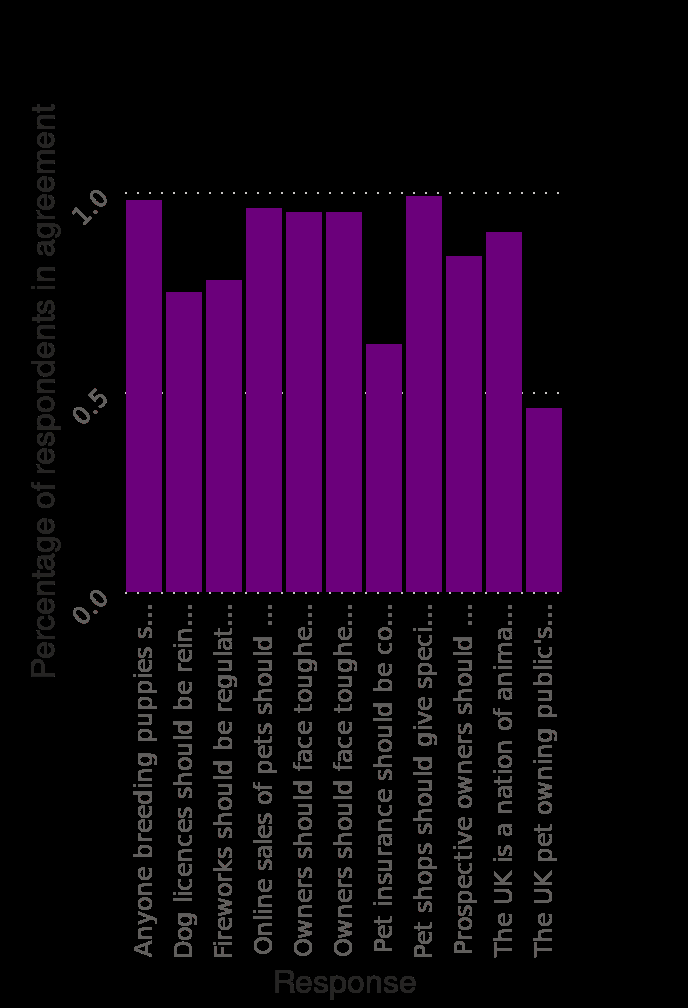<image>
Describe the following image in detail This is a bar diagram titled Veterinary professionals views on issues concerning pet ownership and choosing a pet in the United Kingdom (UK) in 2016. A categorical scale starting at Anyone breeding puppies should be licensed and regulated to meet certain standards. and ending at  can be found on the x-axis, marked Response. A linear scale with a minimum of 0.0 and a maximum of 1.0 can be found along the y-axis, marked Percentage of respondents in agreement. What was the highest percentage of respondents agreeing with any of the issues? The highest percentage of respondents agreeing with any of the issues was 1%. What is the title of the bar diagram? The title of the bar diagram is "Veterinary professionals views on issues concerning pet ownership and choosing a pet in the United Kingdom (UK) in 2016." What range of values does the y-axis cover? The y-axis covers a range of values from a minimum of 0.0 to a maximum of 1.0. 